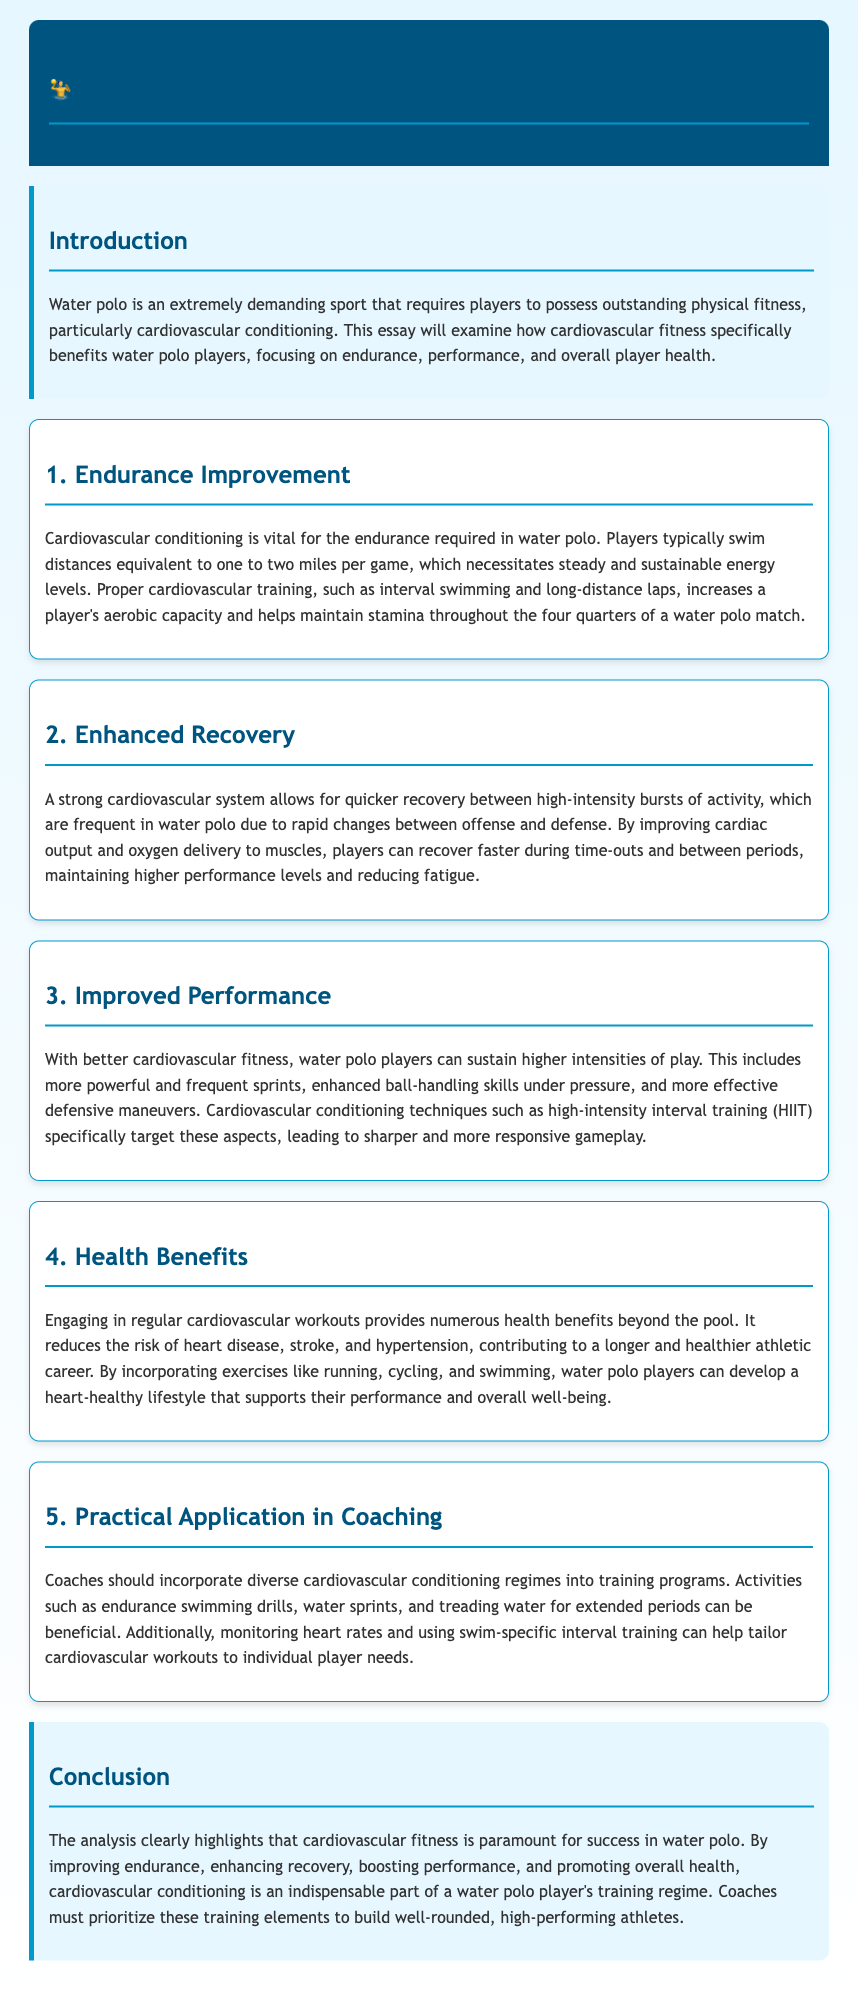What is a primary benefit of cardiovascular conditioning for water polo players? The document states that cardiovascular conditioning specifically benefits water polo players by improving endurance, allowing them to sustain energy levels during games.
Answer: Endurance How far do players typically swim in a game? The essay mentions that players swim distances equivalent to one to two miles per game, which highlights the physical demands of the sport.
Answer: One to two miles What technique is mentioned for improving performance? The document refers to high-intensity interval training (HIIT) as a technique that targets aspects of performance for water polo players.
Answer: High-intensity interval training (HIIT) What is one health benefit of regular cardiovascular workouts? The essay outlines that regular cardiovascular workouts reduce the risk of heart disease, thereby contributing to overall health and well-being.
Answer: Reduces risk of heart disease What should coaches incorporate into training programs? According to the document, coaches should incorporate diverse cardiovascular conditioning regimes into their training programs to improve player fitness.
Answer: Diverse cardiovascular conditioning regimes 